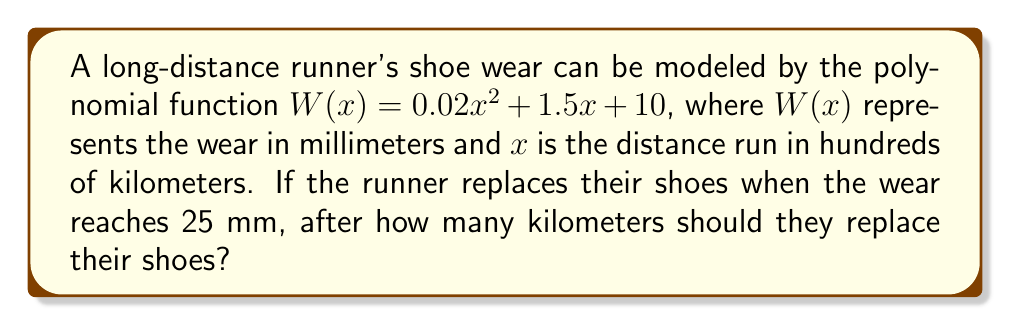Show me your answer to this math problem. To solve this problem, we need to follow these steps:

1) We're looking for the value of $x$ when $W(x) = 25$ mm. This can be represented as an equation:

   $25 = 0.02x^2 + 1.5x + 10$

2) Rearrange the equation to standard form:

   $0.02x^2 + 1.5x - 15 = 0$

3) This is a quadratic equation. We can solve it using the quadratic formula:

   $x = \frac{-b \pm \sqrt{b^2 - 4ac}}{2a}$

   Where $a = 0.02$, $b = 1.5$, and $c = -15$

4) Substituting these values:

   $x = \frac{-1.5 \pm \sqrt{1.5^2 - 4(0.02)(-15)}}{2(0.02)}$

5) Simplify:

   $x = \frac{-1.5 \pm \sqrt{2.25 + 1.2}}{0.04} = \frac{-1.5 \pm \sqrt{3.45}}{0.04}$

6) Calculate:

   $x = \frac{-1.5 \pm 1.8574}{0.04} = \frac{-1.5 + 1.8574}{0.04}$ or $\frac{-1.5 - 1.8574}{0.04}$

7) This gives us two solutions:

   $x = 8.935$ or $x = -83.935$

8) Since distance can't be negative, we take the positive solution: $x = 8.935$

9) Remember, $x$ is in hundreds of kilometers. So we multiply by 100:

   $8.935 * 100 = 893.5$ km
Answer: 893.5 km 